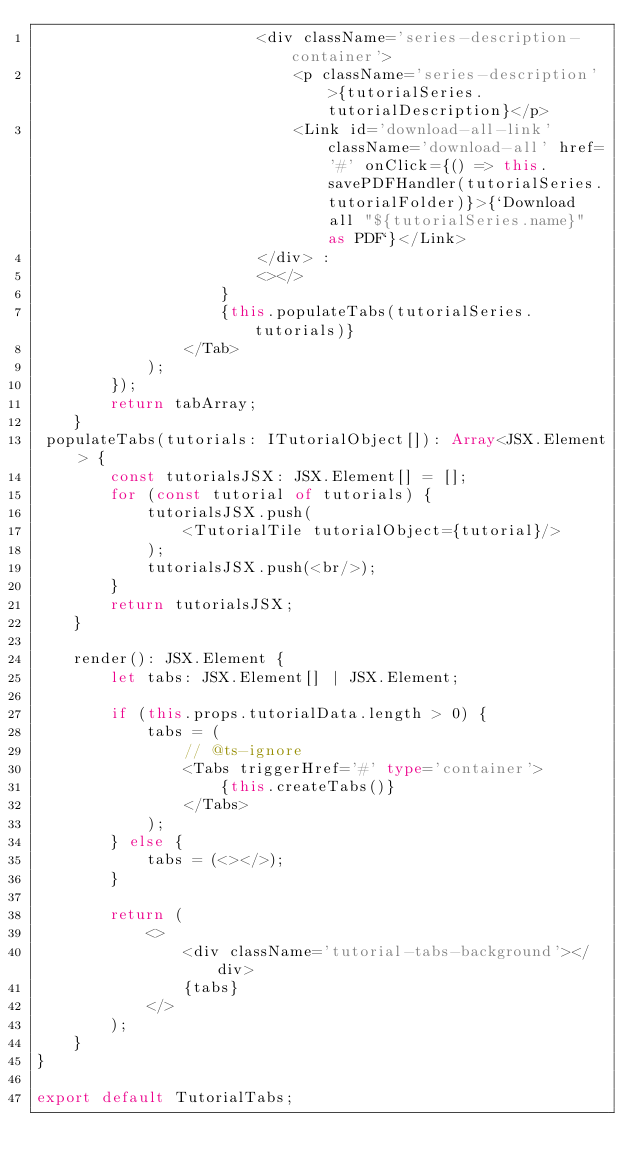<code> <loc_0><loc_0><loc_500><loc_500><_TypeScript_>                        <div className='series-description-container'>
                            <p className='series-description'>{tutorialSeries.tutorialDescription}</p>
                            <Link id='download-all-link' className='download-all' href='#' onClick={() => this.savePDFHandler(tutorialSeries.tutorialFolder)}>{`Download all "${tutorialSeries.name}" as PDF`}</Link>
                        </div> :
                        <></>
                    }
                    {this.populateTabs(tutorialSeries.tutorials)}
                </Tab>
            );
        });
        return tabArray;
    }
 populateTabs(tutorials: ITutorialObject[]): Array<JSX.Element> {
        const tutorialsJSX: JSX.Element[] = [];
        for (const tutorial of tutorials) {
            tutorialsJSX.push(
                <TutorialTile tutorialObject={tutorial}/>
            );
            tutorialsJSX.push(<br/>);
        }
        return tutorialsJSX;
    }

    render(): JSX.Element {
        let tabs: JSX.Element[] | JSX.Element;

        if (this.props.tutorialData.length > 0) {
            tabs = (
                // @ts-ignore
                <Tabs triggerHref='#' type='container'>
                    {this.createTabs()}
                </Tabs>
            );
        } else {
            tabs = (<></>);
        }

        return (
            <>
                <div className='tutorial-tabs-background'></div>
                {tabs}
            </>
        );
    }
}

export default TutorialTabs;
</code> 